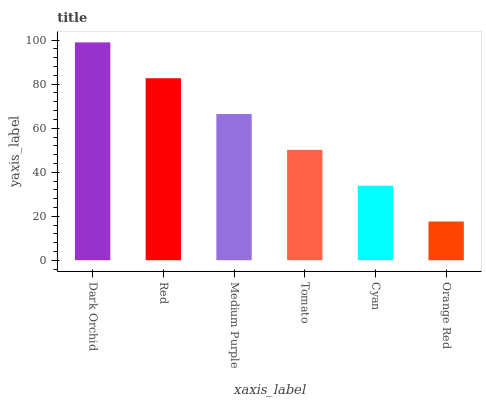Is Orange Red the minimum?
Answer yes or no. Yes. Is Dark Orchid the maximum?
Answer yes or no. Yes. Is Red the minimum?
Answer yes or no. No. Is Red the maximum?
Answer yes or no. No. Is Dark Orchid greater than Red?
Answer yes or no. Yes. Is Red less than Dark Orchid?
Answer yes or no. Yes. Is Red greater than Dark Orchid?
Answer yes or no. No. Is Dark Orchid less than Red?
Answer yes or no. No. Is Medium Purple the high median?
Answer yes or no. Yes. Is Tomato the low median?
Answer yes or no. Yes. Is Dark Orchid the high median?
Answer yes or no. No. Is Orange Red the low median?
Answer yes or no. No. 